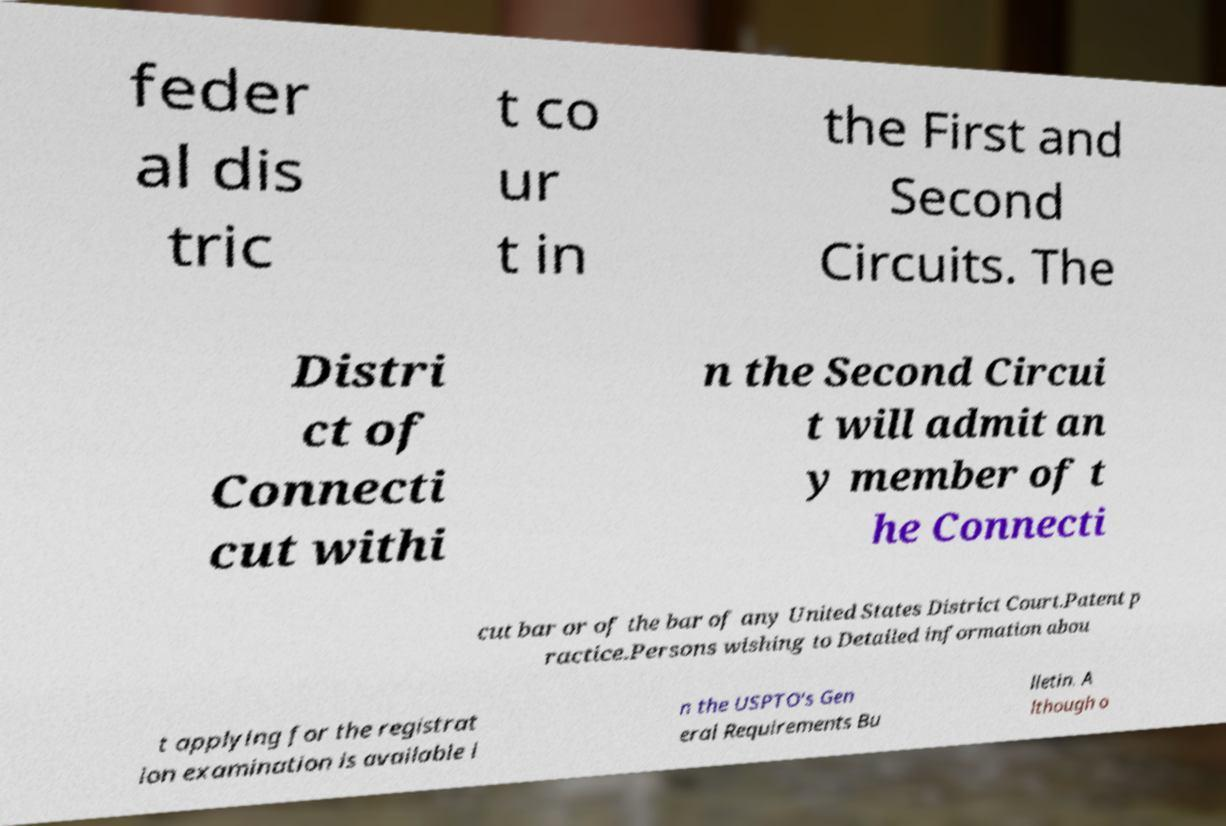What messages or text are displayed in this image? I need them in a readable, typed format. feder al dis tric t co ur t in the First and Second Circuits. The Distri ct of Connecti cut withi n the Second Circui t will admit an y member of t he Connecti cut bar or of the bar of any United States District Court.Patent p ractice.Persons wishing to Detailed information abou t applying for the registrat ion examination is available i n the USPTO's Gen eral Requirements Bu lletin. A lthough o 